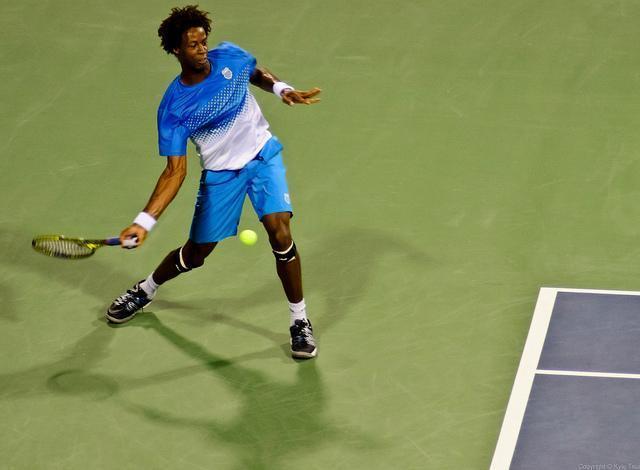How many feet are on the ground?
Give a very brief answer. 2. 